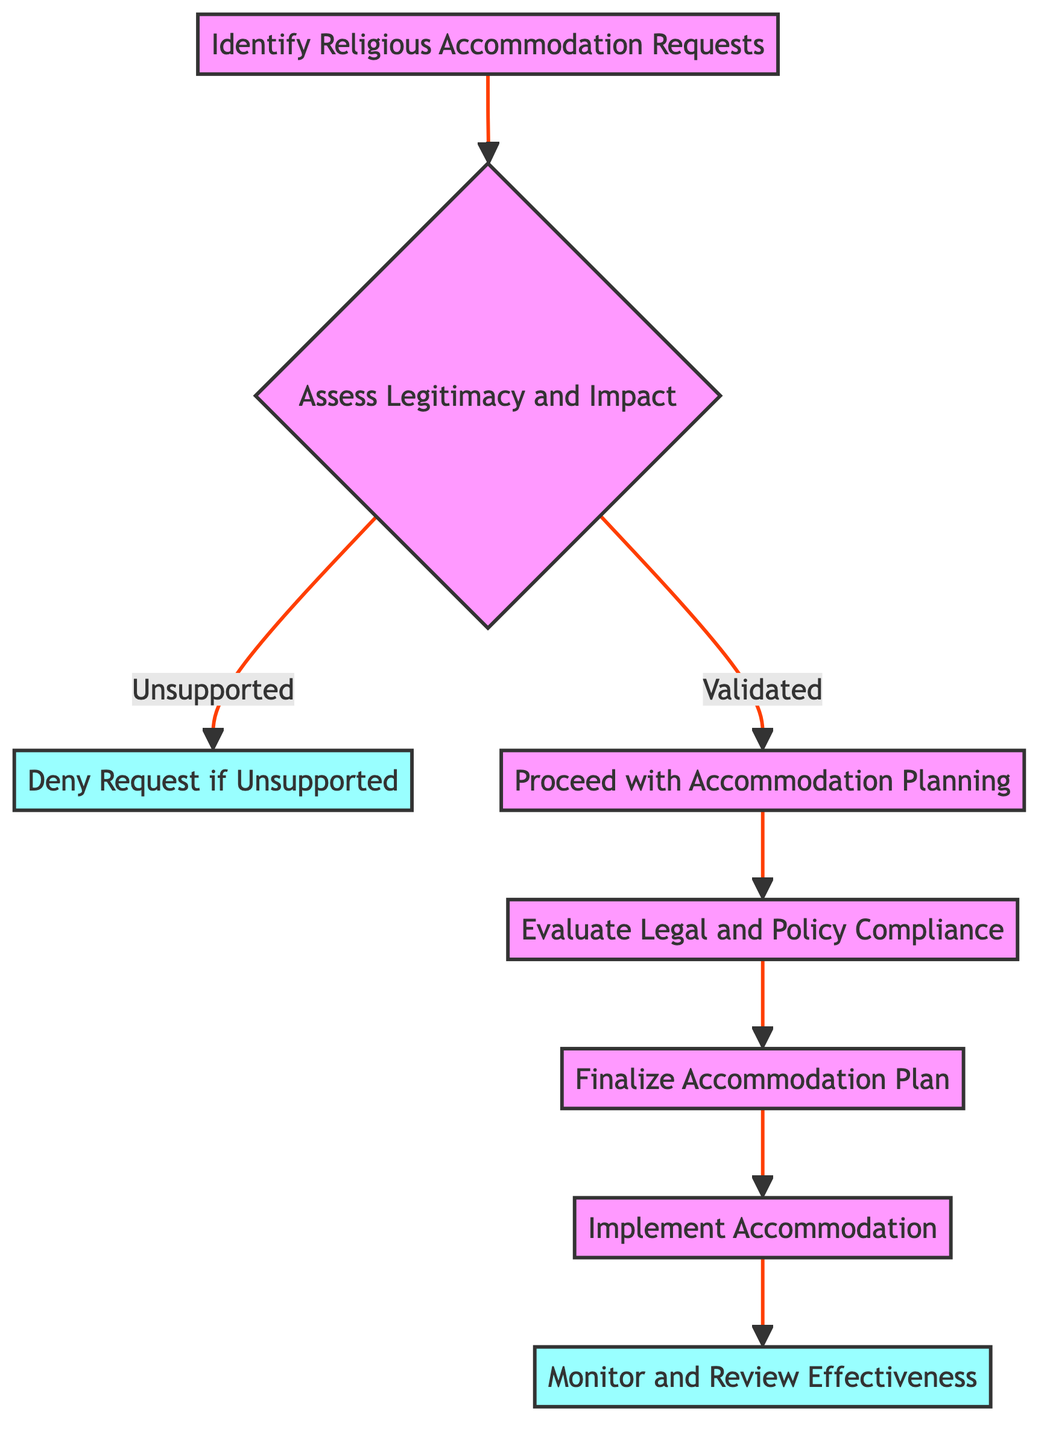What is the first step in the process? The diagram starts with the first node labeled "Identify Religious Accommodation Requests," which indicates that this is the initial action to be taken.
Answer: Identify Religious Accommodation Requests How many total nodes are in the diagram? The diagram contains 8 nodes, which are represented by each distinct step in the process.
Answer: 8 What action follows "Assess Legitimacy and Impact" if the request is validated? If the request is validated, the next step is "Proceed with Accommodation Planning," which is the subsequent action in the flowchart.
Answer: Proceed with Accommodation Planning What happens if the request is unsupported after the assessment? If the request is unsupported, the process leads to "Deny Request if Unsupported," which denotes the end of the flow after notifying the employee.
Answer: Deny Request if Unsupported What is the final step in the process? The last action in the flowchart is "Monitor and Review Effectiveness," which indicates the continuous oversight needed for the accommodation.
Answer: Monitor and Review Effectiveness How many paths lead to an endpoint in the diagram? There are two endpoints in the diagram: "Deny Request if Unsupported" and "Monitor and Review Effectiveness," indicating they are the final steps that conclude the process.
Answer: 2 What must be validated before proceeding with accommodation planning? Before proceeding, the legitimacy and impact of the request must be validated, which is the critical evaluation step in the process.
Answer: Legitimacy and Impact What ensures that the accommodation complies with relevant laws? The node "Evaluate Legal and Policy Compliance" ensures that the accommodation adheres to Title VII of the Civil Rights Act and company policies.
Answer: Evaluate Legal and Policy Compliance 